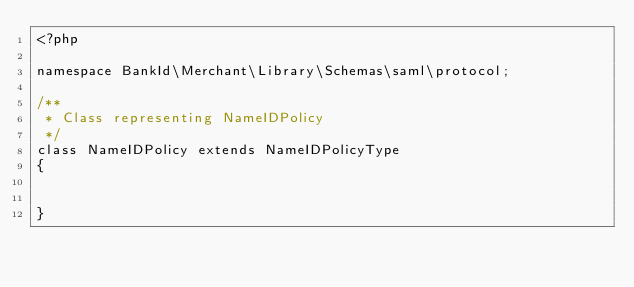Convert code to text. <code><loc_0><loc_0><loc_500><loc_500><_PHP_><?php

namespace BankId\Merchant\Library\Schemas\saml\protocol;

/**
 * Class representing NameIDPolicy
 */
class NameIDPolicy extends NameIDPolicyType
{


}

</code> 